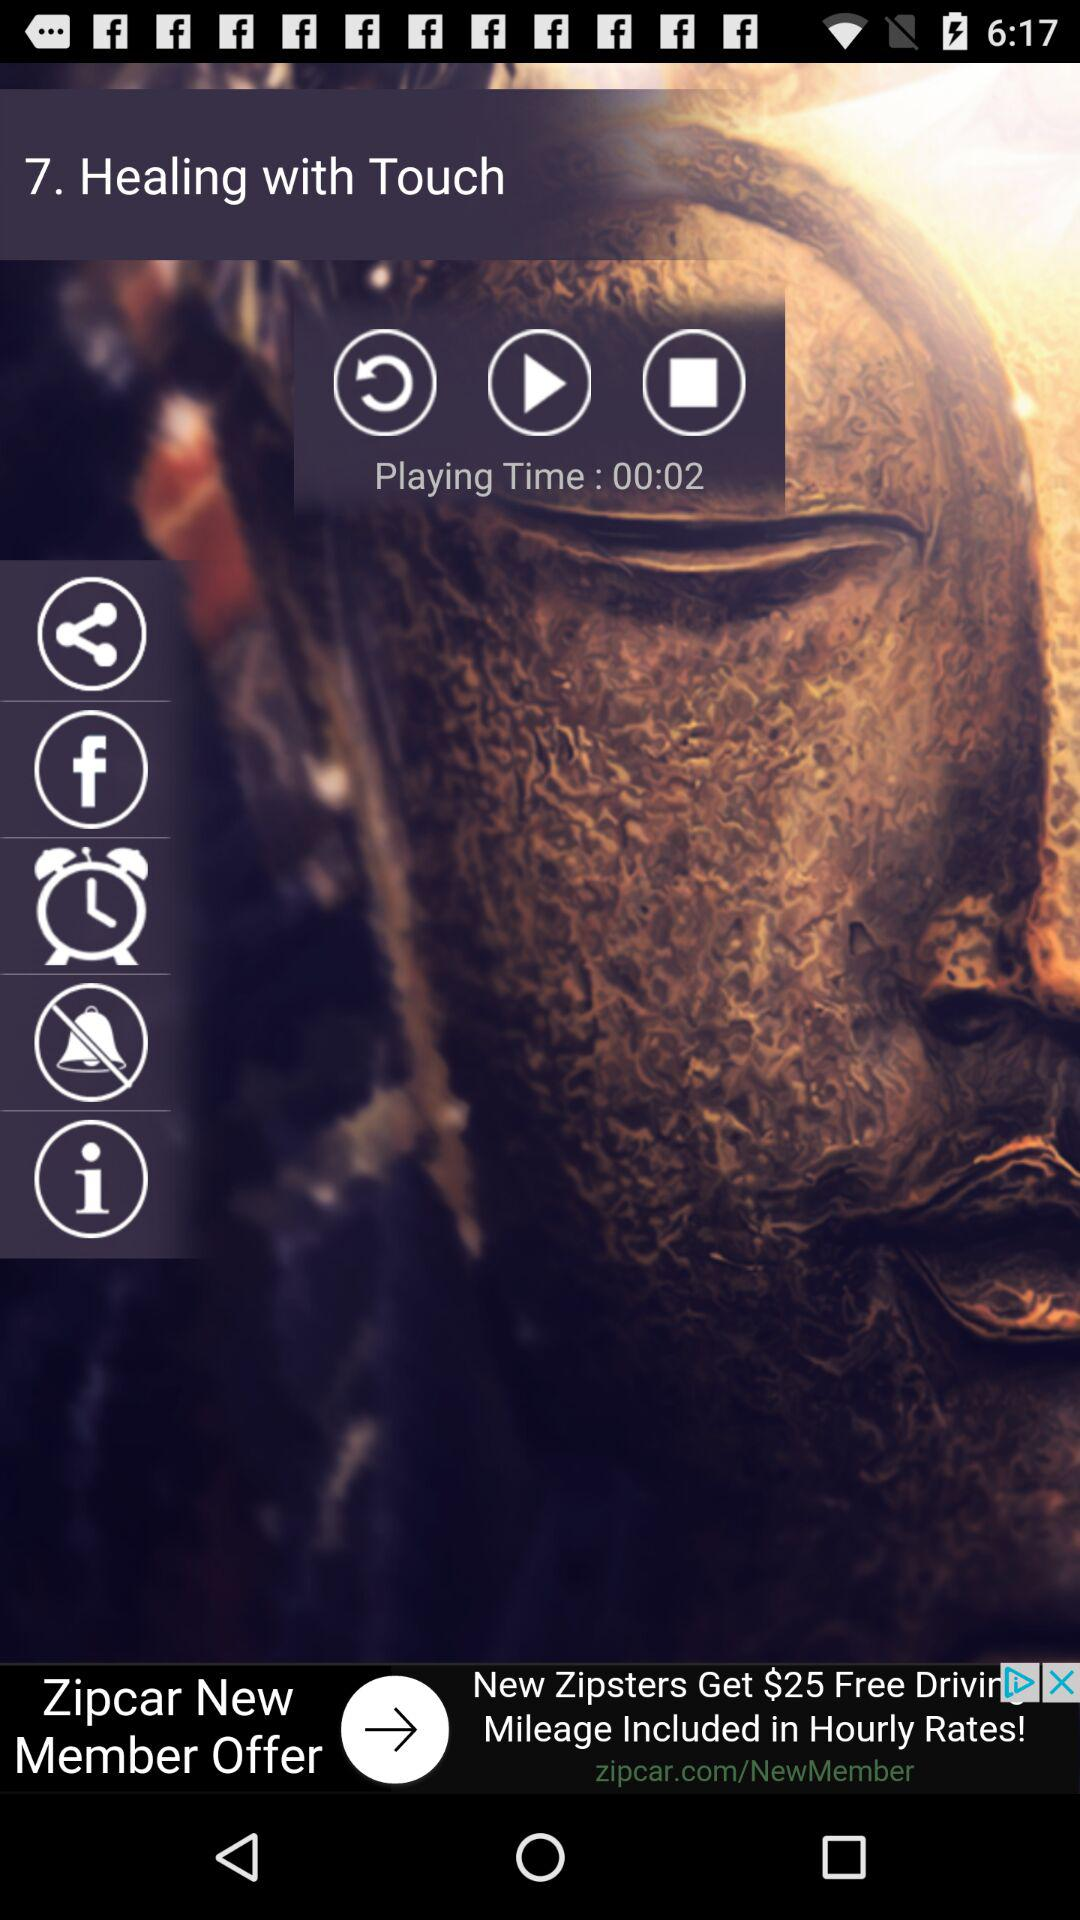How many seconds has the video been playing for?
Answer the question using a single word or phrase. 2 